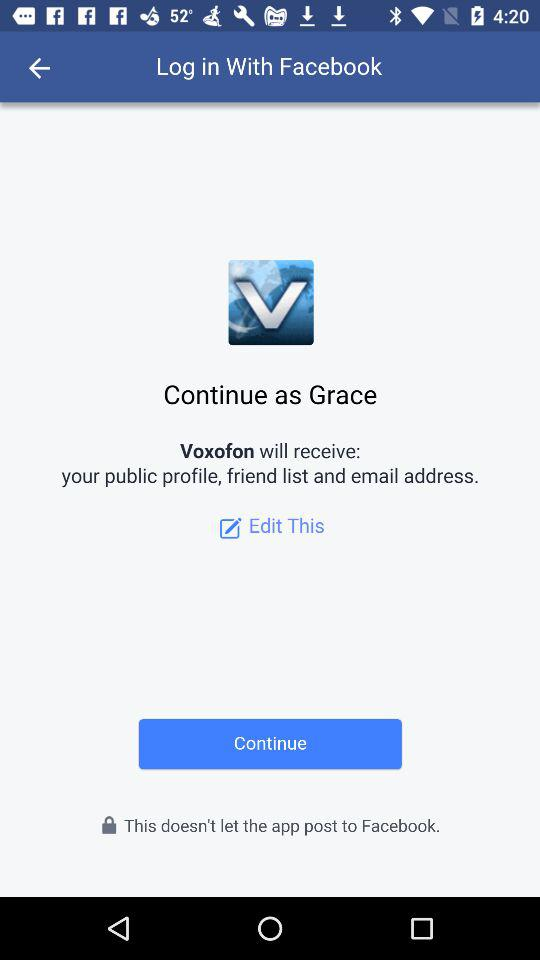What application is asking for permission? The application asking for permission is "Voxofon". 